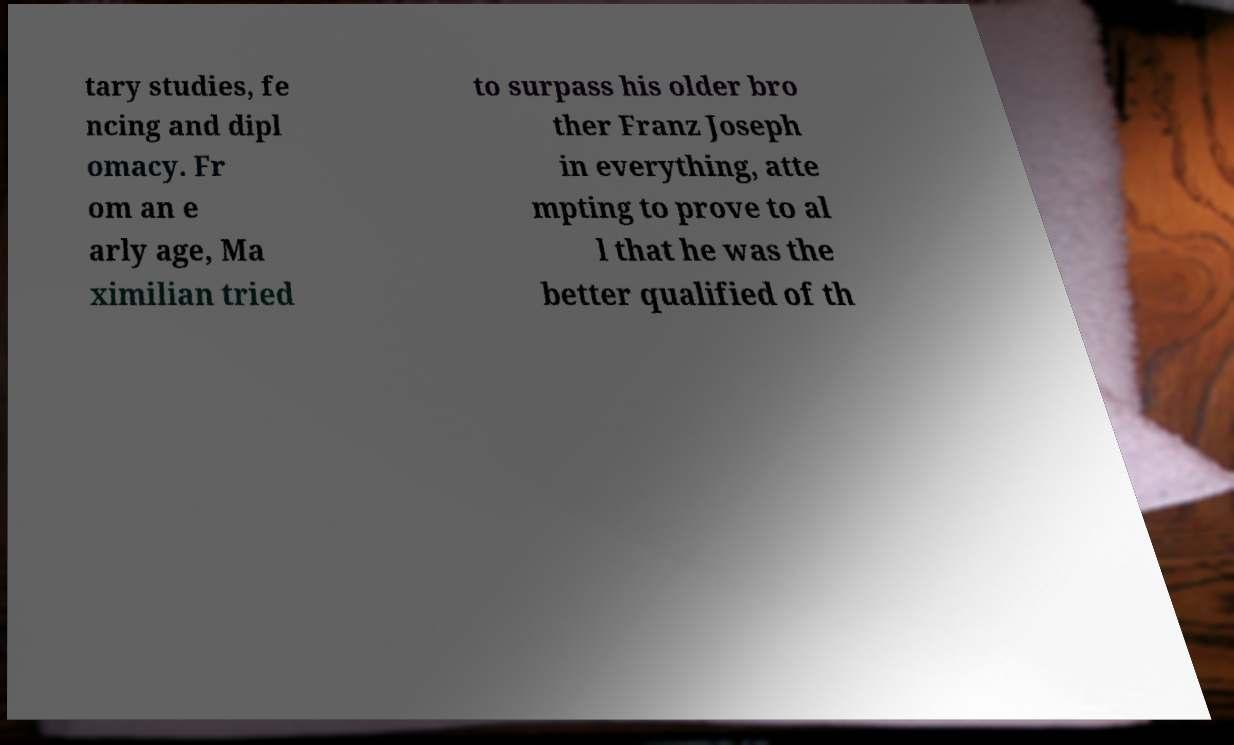Could you extract and type out the text from this image? tary studies, fe ncing and dipl omacy. Fr om an e arly age, Ma ximilian tried to surpass his older bro ther Franz Joseph in everything, atte mpting to prove to al l that he was the better qualified of th 